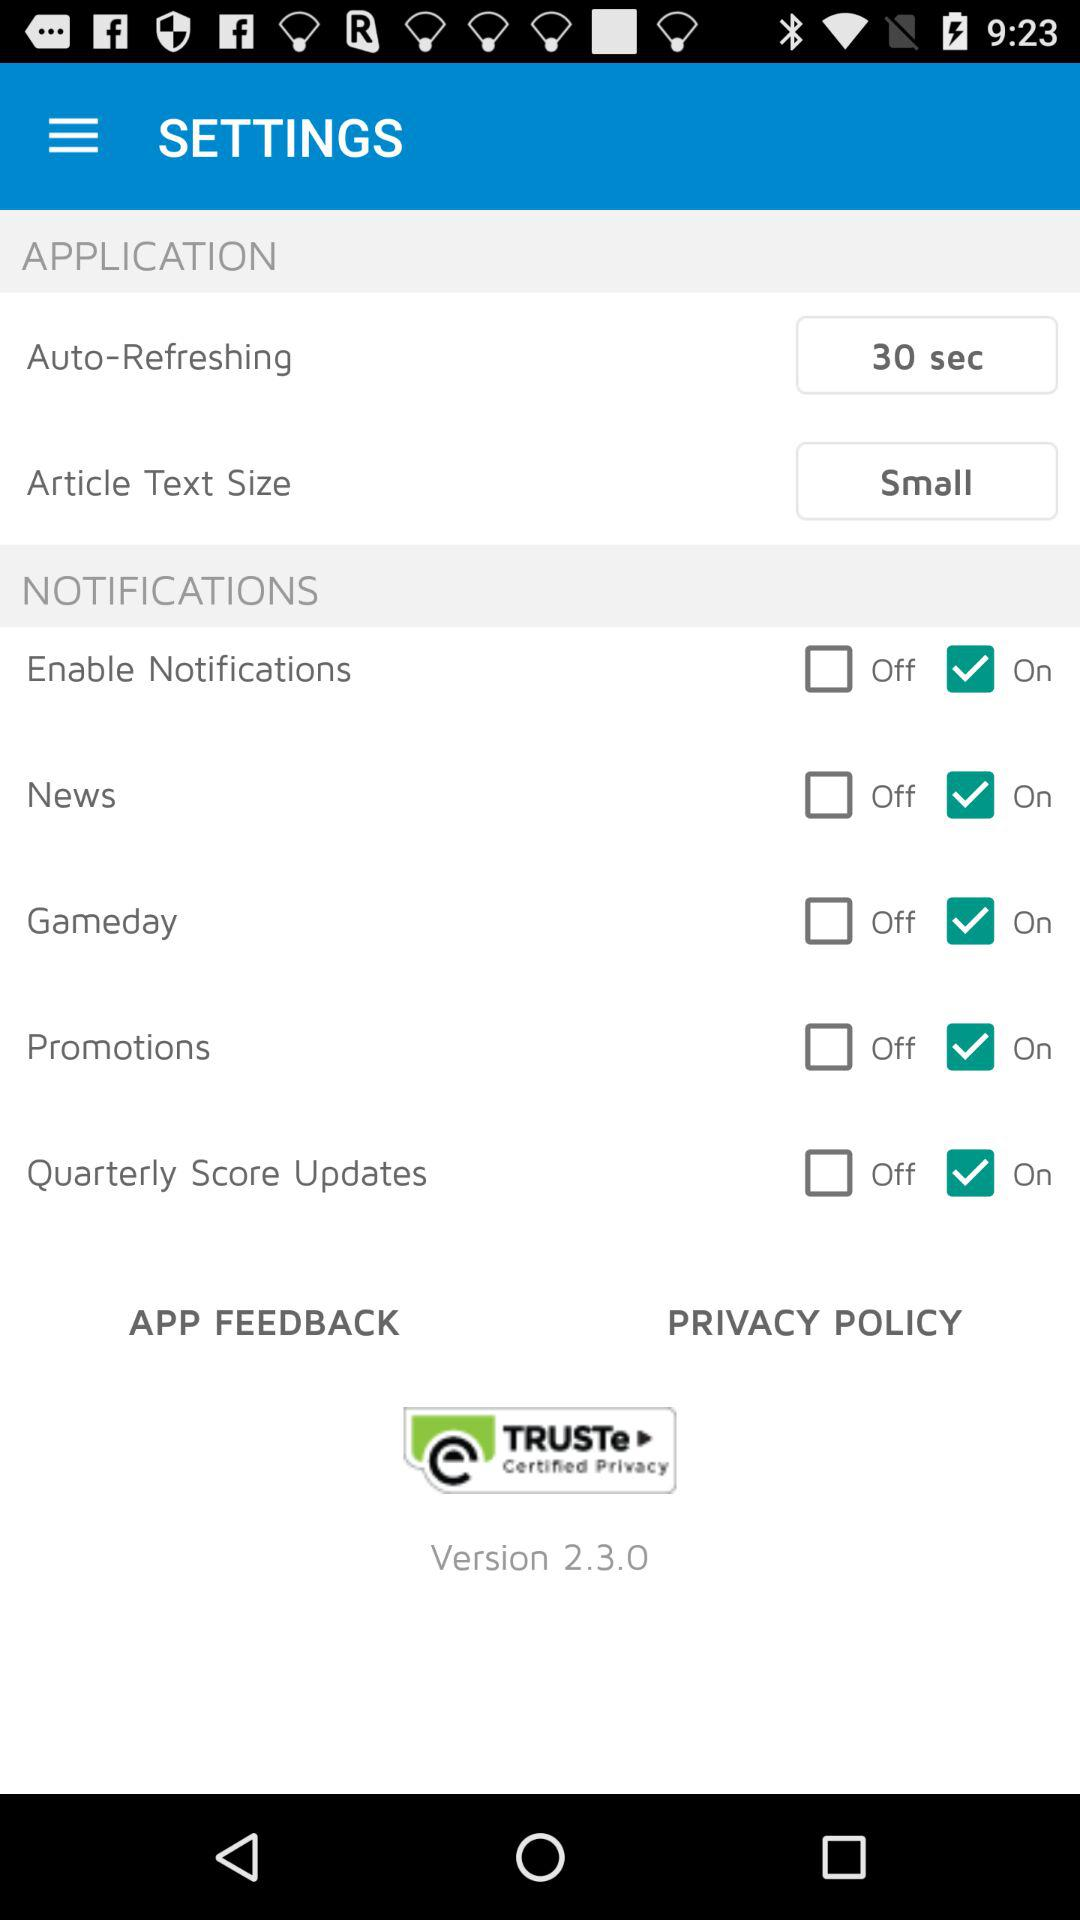What is the "Auto-Refreshing" duration? The "Auto-Refreshing" duration is 30 seconds. 